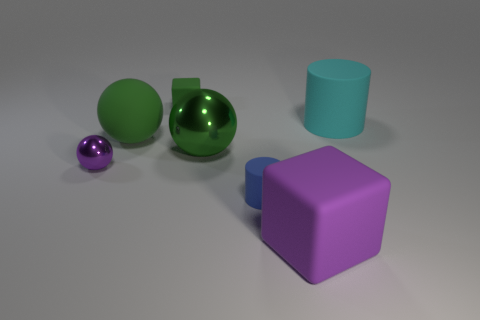Add 3 small green matte cubes. How many objects exist? 10 Subtract all balls. How many objects are left? 4 Subtract 0 purple cylinders. How many objects are left? 7 Subtract all tiny matte cylinders. Subtract all green metal objects. How many objects are left? 5 Add 7 green blocks. How many green blocks are left? 8 Add 5 big red blocks. How many big red blocks exist? 5 